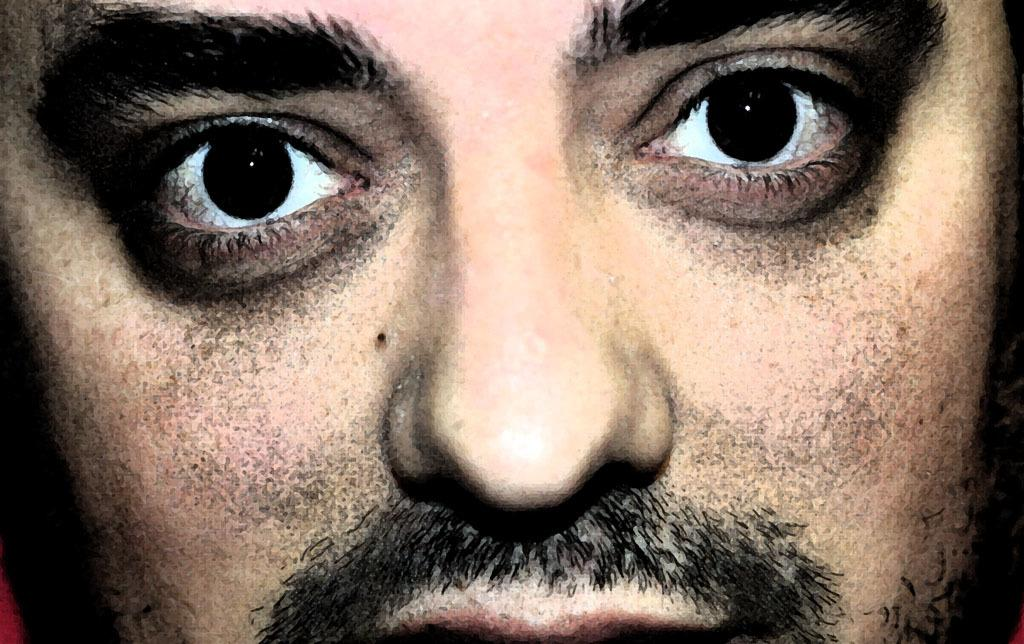What part of a person is depicted in the image? There is a man's face in the image. What specific facial features can be seen in the image? The man's eyes, nose, and mouth are visible in the image. Is there any indication that the image has been altered or edited? The image might be edited, as it is mentioned in the facts. What type of game is the man playing in the image? There is no game present in the image; it only depicts a man's face with visible eyes, nose, and mouth. What sound does the man make when he sees the nut in the image? There is no nut or sound of laughter present in the image; it only shows a man's face with visible facial features. 